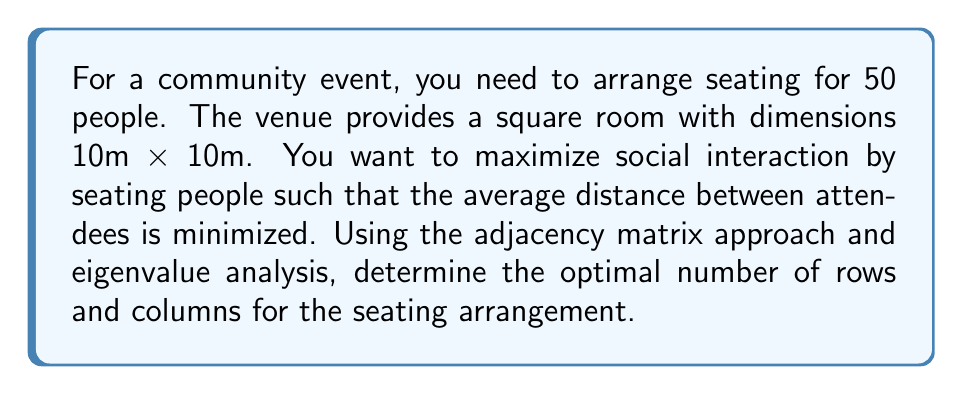Can you solve this math problem? Let's approach this step-by-step:

1) First, we need to create an adjacency matrix for the seating arrangement. Let's assume we have $r$ rows and $c$ columns, where $r \times c = 50$.

2) The adjacency matrix $A$ will be of size $50 \times 50$, where $A_{ij} = 1$ if person $i$ is adjacent to person $j$, and 0 otherwise.

3) The eigenvalues of this matrix will give us information about the connectivity of the seating arrangement. The largest eigenvalue (spectral radius) is particularly important, as it represents the overall connectivity.

4) For a grid-like seating arrangement, the spectral radius is approximately given by:

   $$\lambda_{\text{max}} \approx 2\sqrt{d-1}$$

   where $d$ is the average degree (number of adjacent seats) per person.

5) In a grid arrangement, most people will have 4 adjacent seats (up, down, left, right), except those on the edges and corners. So, we can approximate:

   $$d \approx 4 - \frac{2(r+c)}{rc} + \frac{4}{rc}$$

6) Our goal is to maximize $\lambda_{\text{max}}$, which means maximizing $d$.

7) Given the constraint $r \times c = 50$, we can try different combinations:
   - 5 x 10: $d \approx 3.44$, $\lambda_{\text{max}} \approx 3.40$
   - 7 x 7: $d \approx 3.51$, $\lambda_{\text{max}} \approx 3.46$
   - 5 x 10: $d \approx 3.44$, $\lambda_{\text{max}} \approx 3.40$

8) The 7 x 7 arrangement gives the highest $\lambda_{\text{max}}$, indicating the best overall connectivity.

9) This arrangement also fits well with the 10m x 10m room, allowing for approximately 1.4m between rows and columns, which is a comfortable distance for social interaction.
Answer: 7 rows and 7 columns (plus 1 extra seat) 